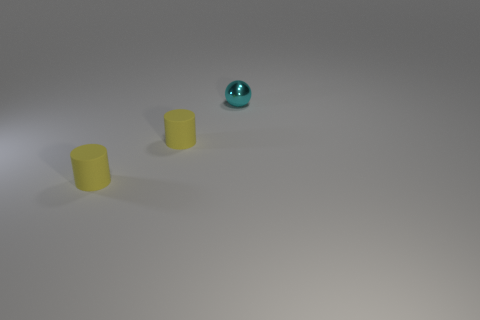Add 1 rubber things. How many objects exist? 4 Subtract 1 balls. How many balls are left? 0 Subtract all cylinders. How many objects are left? 1 Add 1 cyan metal spheres. How many cyan metal spheres are left? 2 Add 2 small cyan shiny balls. How many small cyan shiny balls exist? 3 Subtract 0 gray cubes. How many objects are left? 3 Subtract all yellow balls. Subtract all yellow cylinders. How many balls are left? 1 Subtract all green cylinders. How many brown spheres are left? 0 Subtract all yellow things. Subtract all cyan spheres. How many objects are left? 0 